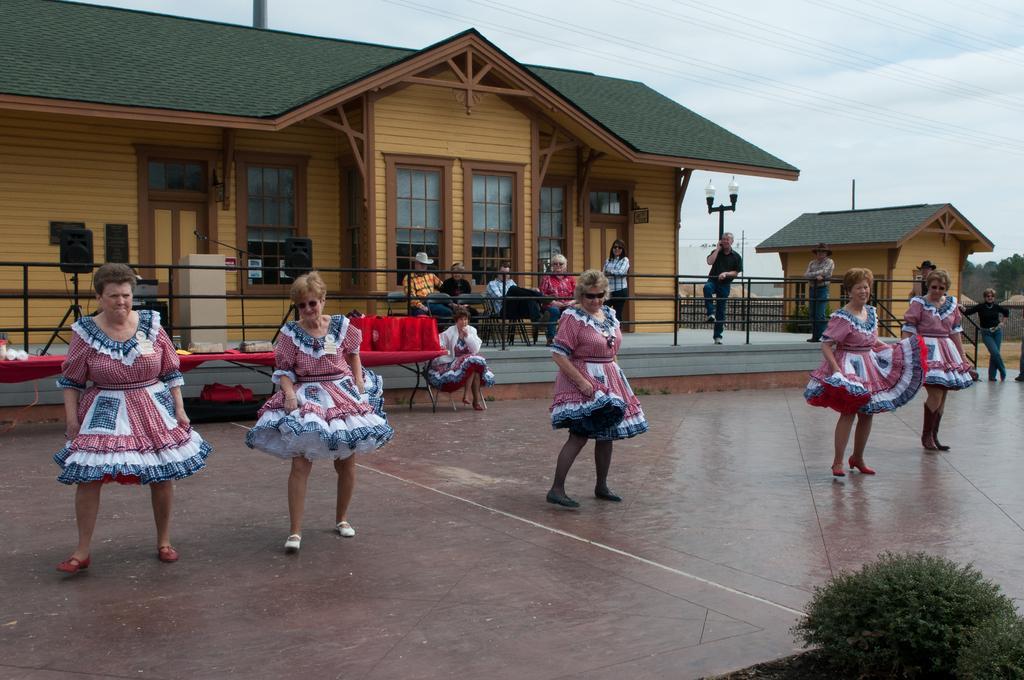How would you summarize this image in a sentence or two? In this image there are group of people dancing, there are group of people sitting on the chairs, houses, lighted, table, trees, and in the background there is sky. 